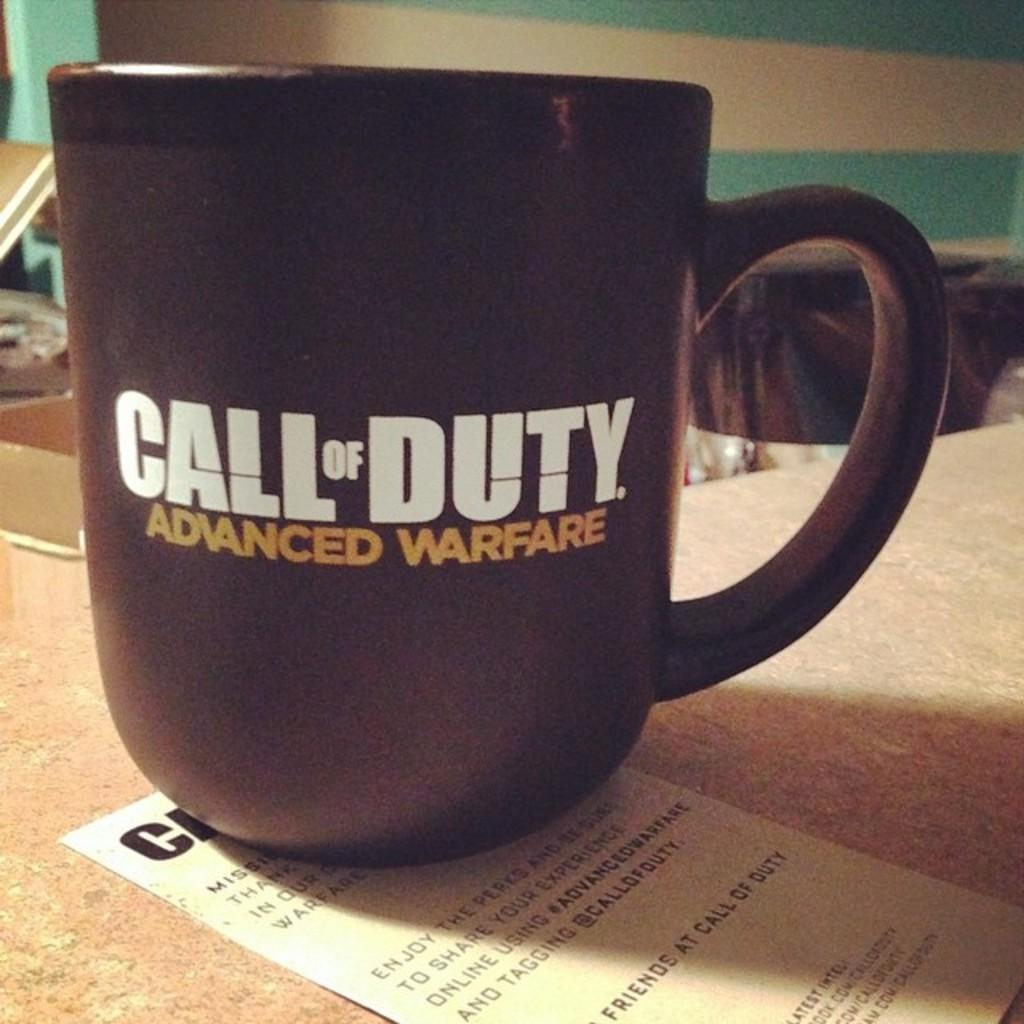Provide a one-sentence caption for the provided image. A black Call of Duty Advanced Warfare mug sits on top of a piece of paper. 